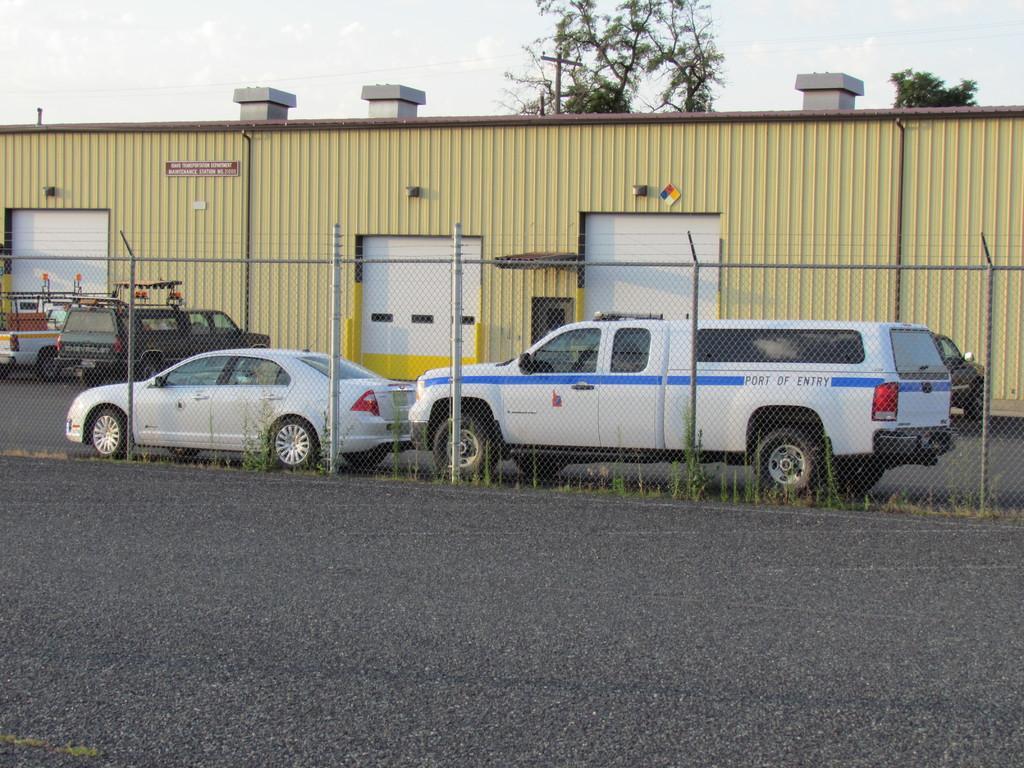Please provide a concise description of this image. In this image there are so many vehicles on the road on the left side there is a fence and on right side there is a shed behind that there are so many trees. 